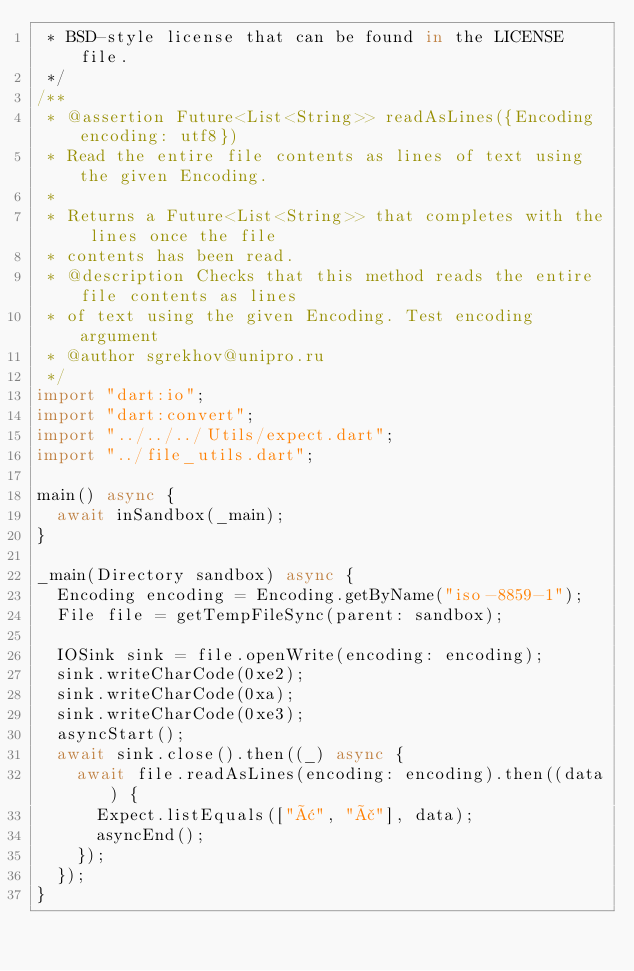Convert code to text. <code><loc_0><loc_0><loc_500><loc_500><_Dart_> * BSD-style license that can be found in the LICENSE file.
 */
/**
 * @assertion Future<List<String>> readAsLines({Encoding encoding: utf8})
 * Read the entire file contents as lines of text using the given Encoding.
 *
 * Returns a Future<List<String>> that completes with the lines once the file
 * contents has been read.
 * @description Checks that this method reads the entire file contents as lines
 * of text using the given Encoding. Test encoding argument
 * @author sgrekhov@unipro.ru
 */
import "dart:io";
import "dart:convert";
import "../../../Utils/expect.dart";
import "../file_utils.dart";

main() async {
  await inSandbox(_main);
}

_main(Directory sandbox) async {
  Encoding encoding = Encoding.getByName("iso-8859-1");
  File file = getTempFileSync(parent: sandbox);

  IOSink sink = file.openWrite(encoding: encoding);
  sink.writeCharCode(0xe2);
  sink.writeCharCode(0xa);
  sink.writeCharCode(0xe3);
  asyncStart();
  await sink.close().then((_) async {
    await file.readAsLines(encoding: encoding).then((data) {
      Expect.listEquals(["â", "ã"], data);
      asyncEnd();
    });
  });
}
</code> 